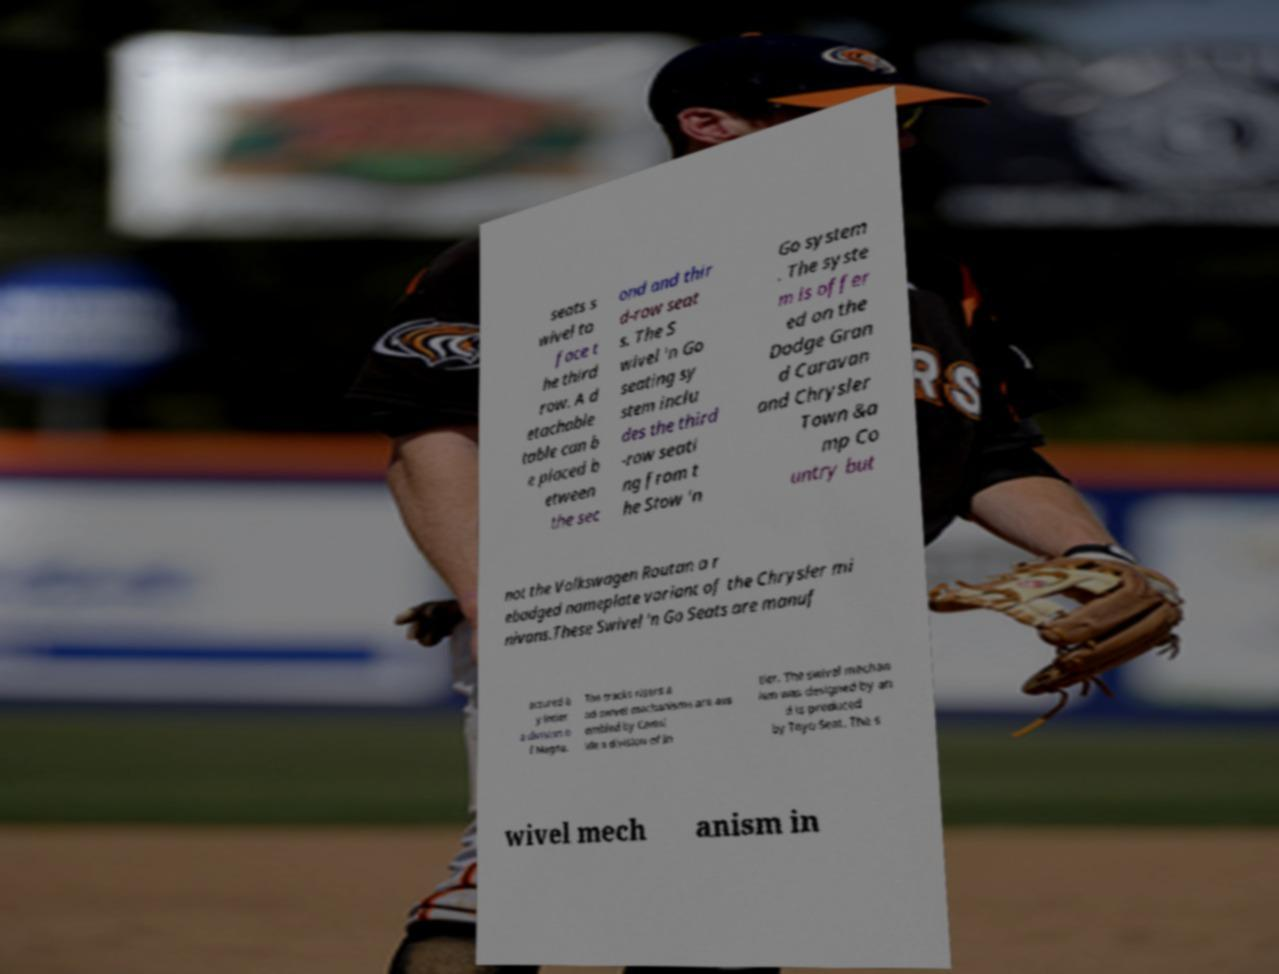Could you extract and type out the text from this image? seats s wivel to face t he third row. A d etachable table can b e placed b etween the sec ond and thir d-row seat s. The S wivel 'n Go seating sy stem inclu des the third -row seati ng from t he Stow 'n Go system . The syste m is offer ed on the Dodge Gran d Caravan and Chrysler Town &a mp Co untry but not the Volkswagen Routan a r ebadged nameplate variant of the Chrysler mi nivans.These Swivel 'n Go Seats are manuf actured b y Intier a division o f Magna. The tracks risers a nd swivel mechanisms are ass embled by Camsl ide a division of In tier. The swivel mechan ism was designed by an d is produced by Toyo Seat. The s wivel mech anism in 